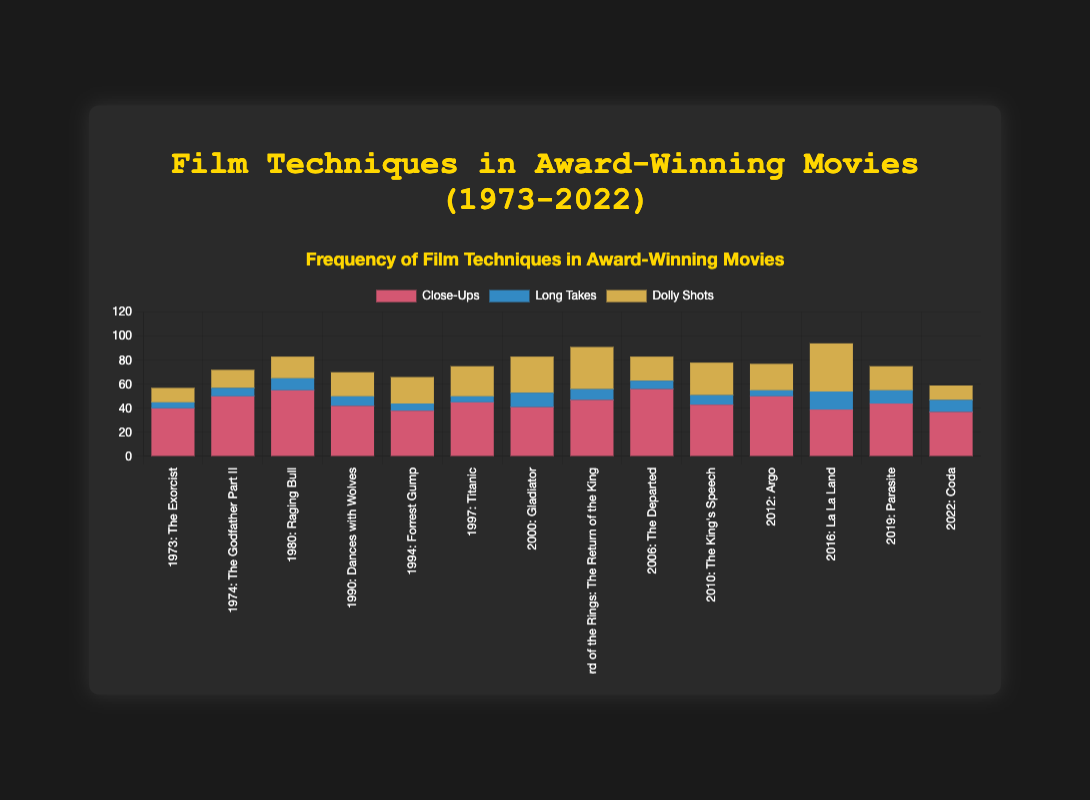What's the frequency of close-ups in "La La Land" and "Titanic" combined? To find the combined frequency, add the number of close-ups in "La La Land" (39) to the number of close-ups in "Titanic" (45): 39 + 45 = 84
Answer: 84 Which film from the 2000s had the highest number of dolly shots? Look at the films from the 2000s (2000-2009), which are "Gladiator" (30 dolly shots), "The Lord of the Rings: The Return of the King" (35 dolly shots), "The Departed" (20 dolly shots), and "The King's Speech" (27 dolly shots). The highest number among these is 35 from "The Lord of the Rings: The Return of the King"
Answer: The Lord of the Rings: The Return of the King How does the number of long takes in "The Exorcist" compare to "Coda"? Long takes in "The Exorcist" are 5, and in "Coda" are 10. 5 is less than 10
Answer: Less What's the total number of dolly shots in the films between 2012 and 2022? Sum the dolly shots for "Argo" (22), "La La Land" (40), "Parasite" (20), and "Coda" (12): 22 + 40 + 20 + 12 = 94
Answer: 94 Which film has the most close-ups and how many? Look for the highest number of close-ups across all films. The film with the most close-ups is "The Departed" with 56 close-ups
Answer: The Departed, 56 What’s the average number of long takes in the films from the 1990s? The films from the 1990s are "Dances with Wolves" (8), "Forrest Gump" (6), and "Titanic" (5). The average = (8 + 6 + 5) / 3 = 19 / 3 = 6.33
Answer: 6.33 Which film from the 1970s had more close-ups, "The Exorcist" or "The Godfather Part II"? "The Exorcist" has 40 close-ups, and "The Godfather Part II" has 50 close-ups. 50 is more than 40
Answer: The Godfather Part II Compare the number of dolly shots in "La La Land" and "Gladiator". Which one has more? "La La Land" has 40 dolly shots, while "Gladiator" has 30. 40 is more than 30
Answer: La La Land What is the difference in the number of close-ups between "Raging Bull" and "Forrest Gump"? "Raging Bull" has 55 close-ups, and "Forrest Gump" has 38 close-ups. The difference is 55 - 38 = 17
Answer: 17 